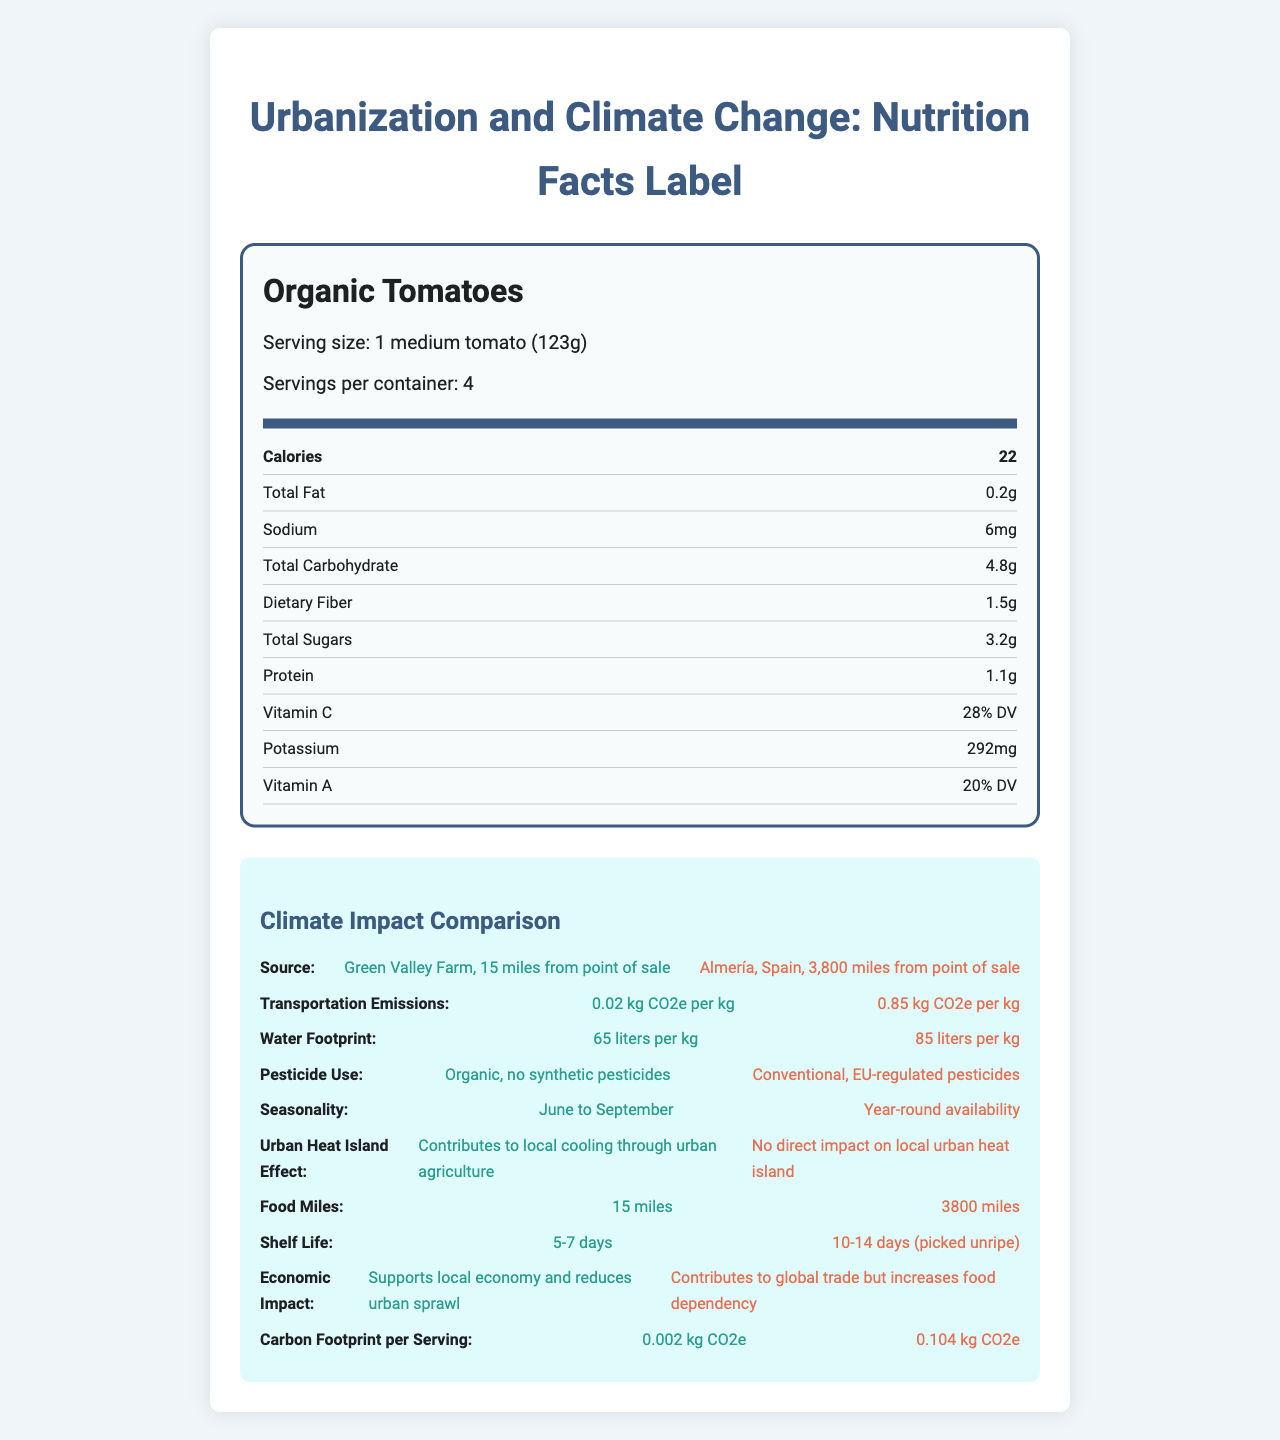what is the serving size for Organic Tomatoes? The serving size is specified at the beginning of the Nutrition Facts Label.
Answer: 1 medium tomato (123g) how many calories per serving does the Organic Tomato have? The number of calories per serving is listed directly under the serving information.
Answer: 22 calories name the local and imported sources for Organic Tomatoes. Under the Climate Impact Comparison section, the sources are listed under "Source".
Answer: Local source: Green Valley Farm, 15 miles from point of sale. Imported source: Almería, Spain, 3,800 miles from point of sale. what is the transportation emission for locally-sourced tomatoes? Transportation emissions for local tomatoes are listed in the Climate Impact Comparison section under "Transportation Emissions".
Answer: 0.02 kg CO2e per kg compare the transportation emissions for locally-sourced and imported tomatoes. The document lists both values under "Transportation Emissions".
Answer: Local: 0.02 kg CO2e per kg, Imported: 0.85 kg CO2e per kg does the locally-sourced produce use synthetic pesticides? The document states that the local tomatoes are organic and use no synthetic pesticides under "Pesticide Use".
Answer: No how much water is used per kg for imported tomatoes? The water footprint for imported tomatoes is listed under "Water Footprint" in the Climate Impact Comparison section.
Answer: 85 liters per kg which tomato source contributes to the local economy and reduces urban sprawl? A. Local Source B. Imported Source The document indicates that the local source supports the local economy and reduces urban sprawl under "Economic Impact."
Answer: A. Local Source which source has a longer shelf life? A. Local Source B. Imported Source The shelf life for imported tomatoes is 10-14 days, whereas local tomatoes have a shelf life of 5-7 days as shown in the Climate Impact Comparison section.
Answer: B. Imported Source based on the document, what are the main advantages of locally-sourced tomatoes over imported tomatoes? The document provides these points in various sections comparing local and imported tomatoes.
Answer: Lower transportation emissions, organic farming, supports local economy, local cooling effect do imported tomatoes have a direct impact on the local urban heat island effect? The document states that imported tomatoes have no direct impact on the local urban heat island effect under "Urban Heat Island Effect."
Answer: No is there any information about the financial cost of local versus imported tomatoes? The document does not provide any financial cost information regarding local versus imported tomatoes.
Answer: Cannot be determined summarize the main idea of the document. The document covers nutritional facts, transportation emissions, water footprint, pesticide use, seasonality, urban heat island effect, food miles, shelf life, and economic impact, highlighting the advantages and disadvantages of local versus imported produce.
Answer: The document provides nutritional information and a detailed comparison of the environmental and economic impacts of locally-sourced versus imported Organic Tomatoes. 